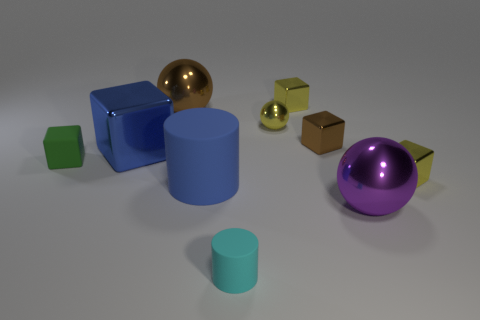Does the tiny cyan rubber object have the same shape as the large rubber thing?
Offer a very short reply. Yes. There is a big thing that is behind the large rubber thing and in front of the yellow ball; what is its material?
Keep it short and to the point. Metal. What number of other objects have the same shape as the large rubber object?
Ensure brevity in your answer.  1. There is a cylinder behind the large metallic ball in front of the sphere behind the small yellow ball; what is its size?
Provide a succinct answer. Large. Is the number of shiny balls in front of the tiny brown block greater than the number of gray matte cylinders?
Make the answer very short. Yes. Is there a gray metallic thing?
Provide a short and direct response. No. How many spheres are the same size as the cyan thing?
Provide a short and direct response. 1. Are there more brown things that are left of the cyan matte object than large brown metal balls in front of the small green object?
Your response must be concise. Yes. There is a cylinder that is the same size as the green rubber cube; what is its material?
Offer a terse response. Rubber. The cyan rubber thing is what shape?
Offer a terse response. Cylinder. 